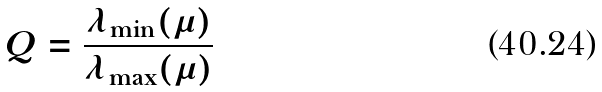<formula> <loc_0><loc_0><loc_500><loc_500>Q = \frac { \lambda _ { \min } ( \mu ) } { \lambda _ { \max } ( \mu ) }</formula> 